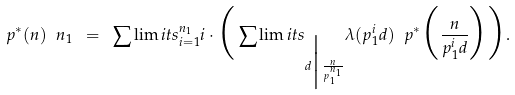<formula> <loc_0><loc_0><loc_500><loc_500>p ^ { * } ( n ) \ n _ { 1 } \ = \ \sum \lim i t s _ { i = 1 } ^ { n _ { 1 } } i \cdot \Big ( \sum \lim i t s _ { d \Big | \frac { n } { p _ { 1 } ^ { n _ { 1 } } } } \lambda ( p _ { 1 } ^ { i } d ) \ p ^ { * } \Big ( \frac { n } { p _ { 1 } ^ { i } d } \Big ) \Big ) .</formula> 